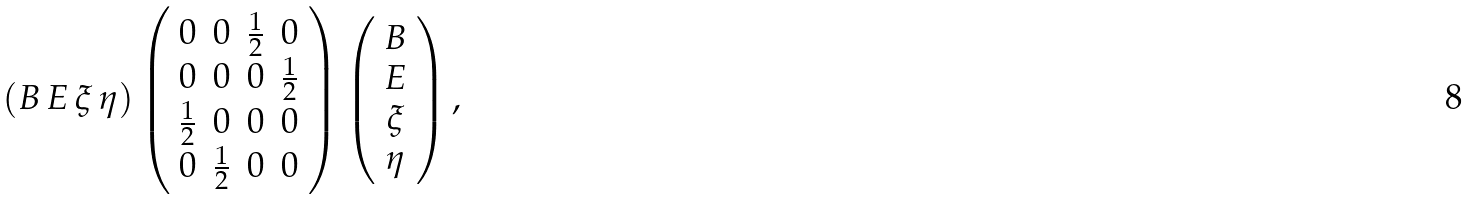Convert formula to latex. <formula><loc_0><loc_0><loc_500><loc_500>( B \, E \, \xi \, \eta ) \left ( \begin{array} { c c c c } 0 & 0 & \frac { 1 } { 2 } & 0 \\ 0 & 0 & 0 & \frac { 1 } { 2 } \\ \frac { 1 } { 2 } & 0 & 0 & 0 \\ 0 & \frac { 1 } { 2 } & 0 & 0 \end{array} \right ) \left ( \begin{array} { c } B \\ E \\ \xi \\ \eta \end{array} \right ) ,</formula> 